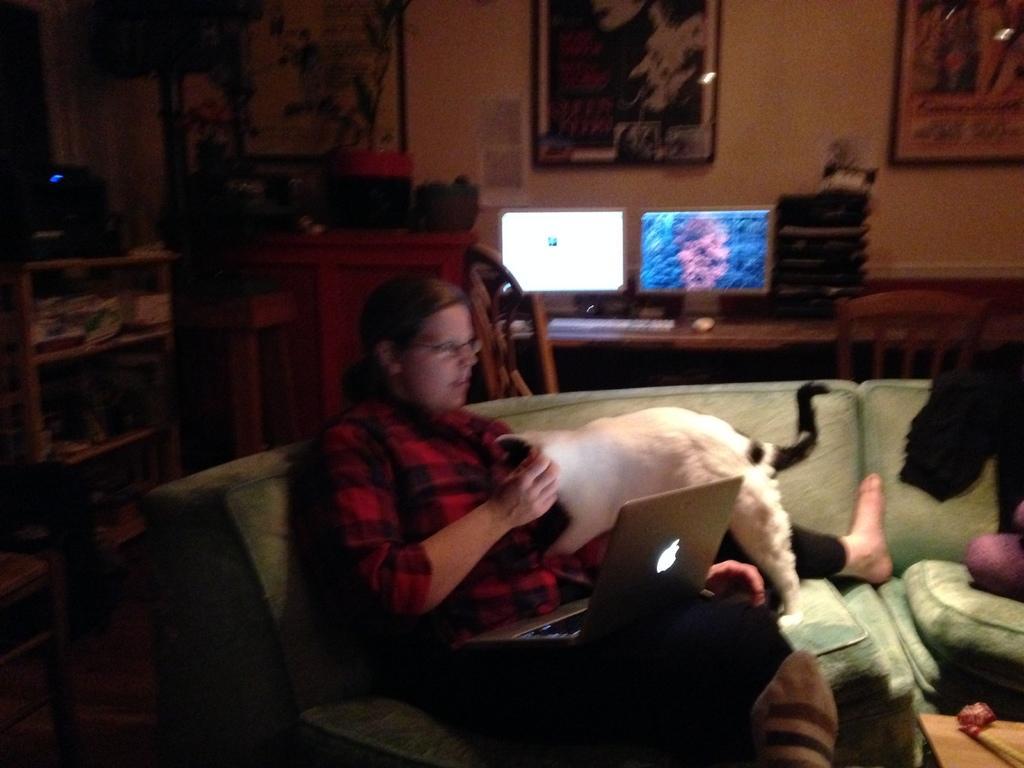How would you summarize this image in a sentence or two? In this picture there is a sofa at the bottom side of the image and there is a lady on the sofa, she is operating a laptop and there is a cat on her laps, there are portraits on the wall and there are racks on the left side of the image and there is a desk in the background area of the image, on which there are two monitors. 